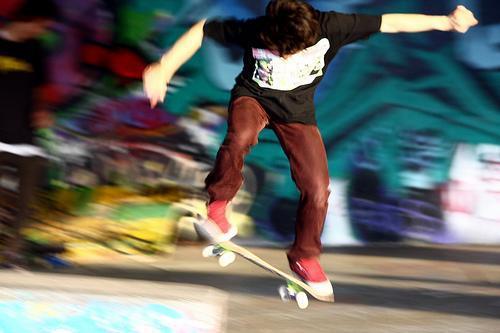How many men skateboarding?
Give a very brief answer. 1. 